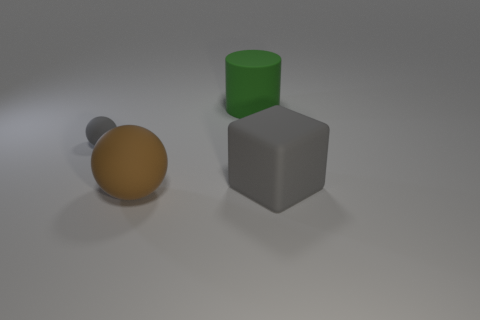There is a gray thing that is on the left side of the large gray rubber cube; is it the same shape as the large thing that is to the right of the large green matte cylinder?
Make the answer very short. No. There is a large matte block; is its color the same as the ball that is behind the large brown sphere?
Your answer should be compact. Yes. Is the color of the rubber ball behind the brown matte ball the same as the big cylinder?
Offer a very short reply. No. How many things are yellow matte spheres or large rubber things to the left of the gray rubber block?
Offer a very short reply. 2. There is a big object that is both in front of the big cylinder and to the left of the big gray object; what material is it?
Provide a succinct answer. Rubber. What material is the large ball that is in front of the big gray thing?
Offer a terse response. Rubber. What color is the big block that is made of the same material as the big brown ball?
Make the answer very short. Gray. Is the shape of the green object the same as the gray object that is on the left side of the big brown matte ball?
Your answer should be compact. No. There is a big brown sphere; are there any brown things to the left of it?
Keep it short and to the point. No. There is a big thing that is the same color as the tiny rubber ball; what is its material?
Provide a succinct answer. Rubber. 